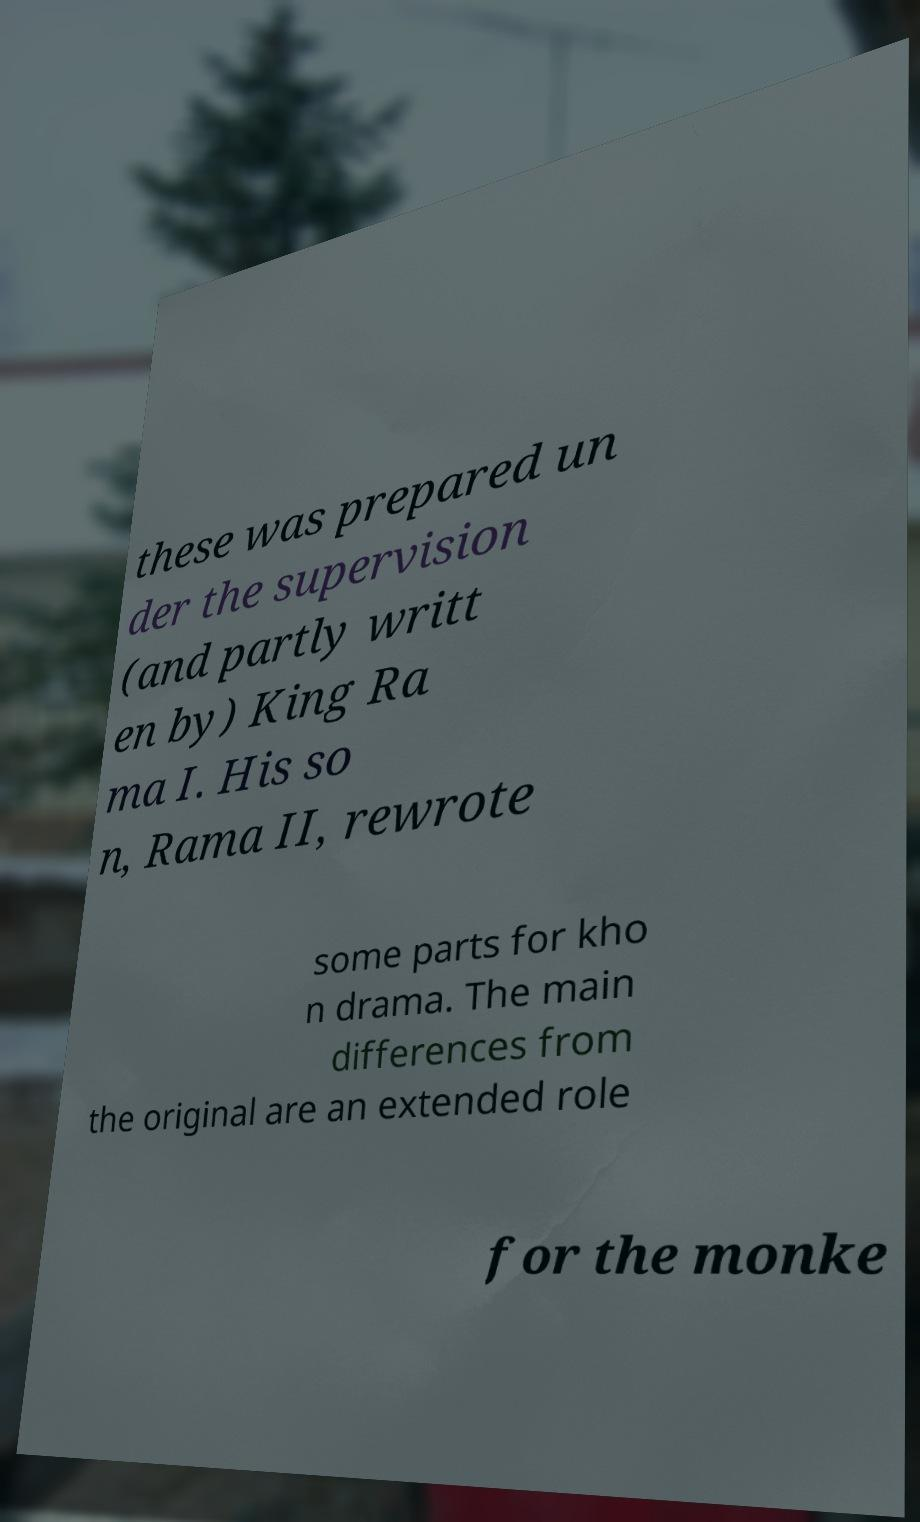Could you extract and type out the text from this image? these was prepared un der the supervision (and partly writt en by) King Ra ma I. His so n, Rama II, rewrote some parts for kho n drama. The main differences from the original are an extended role for the monke 